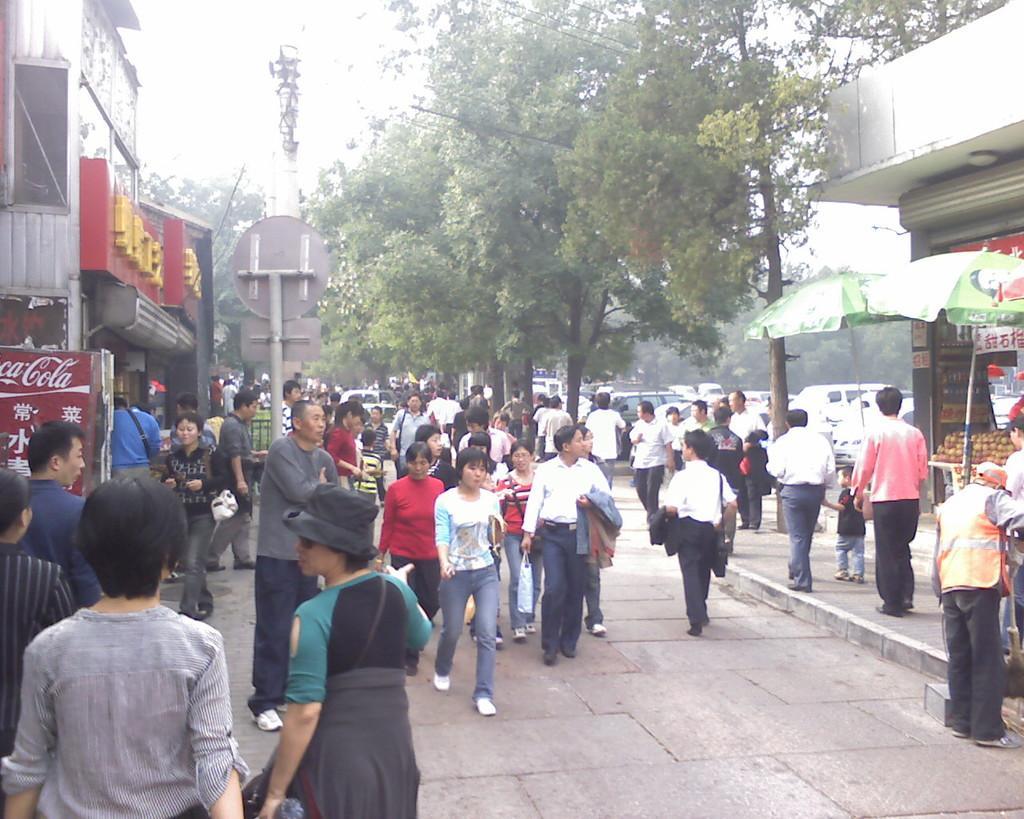How would you summarize this image in a sentence or two? In this picture there are many people in the center of the image and there are trees and cars in the background area of the image and there are stalls on the right and left side of the image and there are poles in the image. 